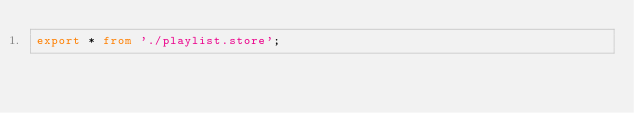Convert code to text. <code><loc_0><loc_0><loc_500><loc_500><_TypeScript_>export * from './playlist.store';
</code> 